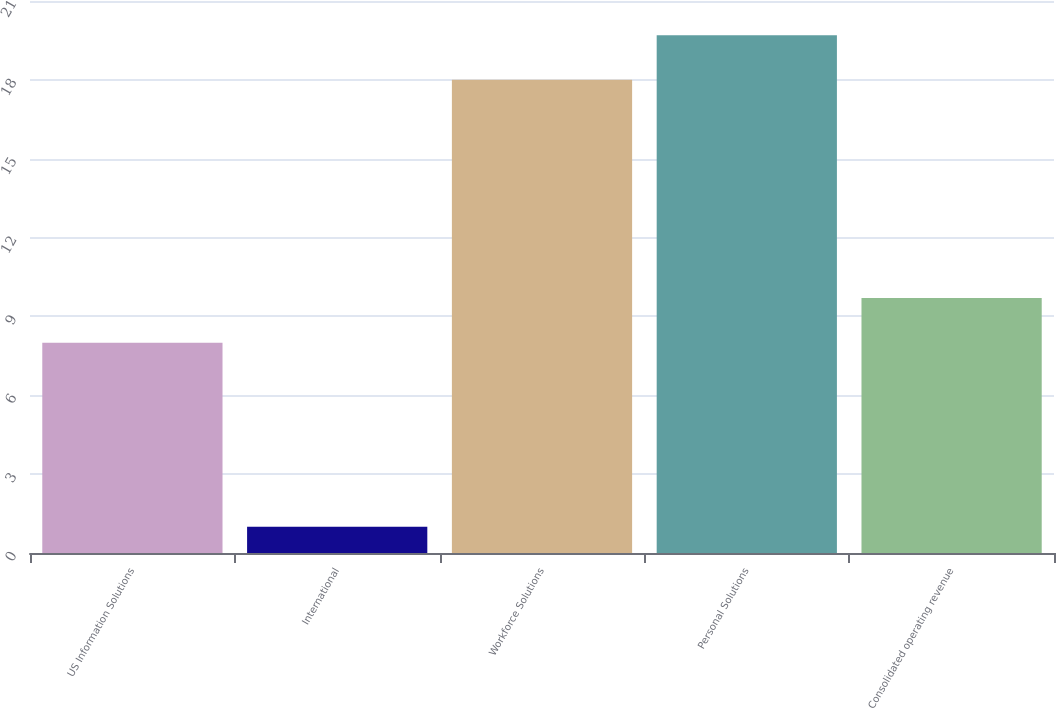Convert chart. <chart><loc_0><loc_0><loc_500><loc_500><bar_chart><fcel>US Information Solutions<fcel>International<fcel>Workforce Solutions<fcel>Personal Solutions<fcel>Consolidated operating revenue<nl><fcel>8<fcel>1<fcel>18<fcel>19.7<fcel>9.7<nl></chart> 